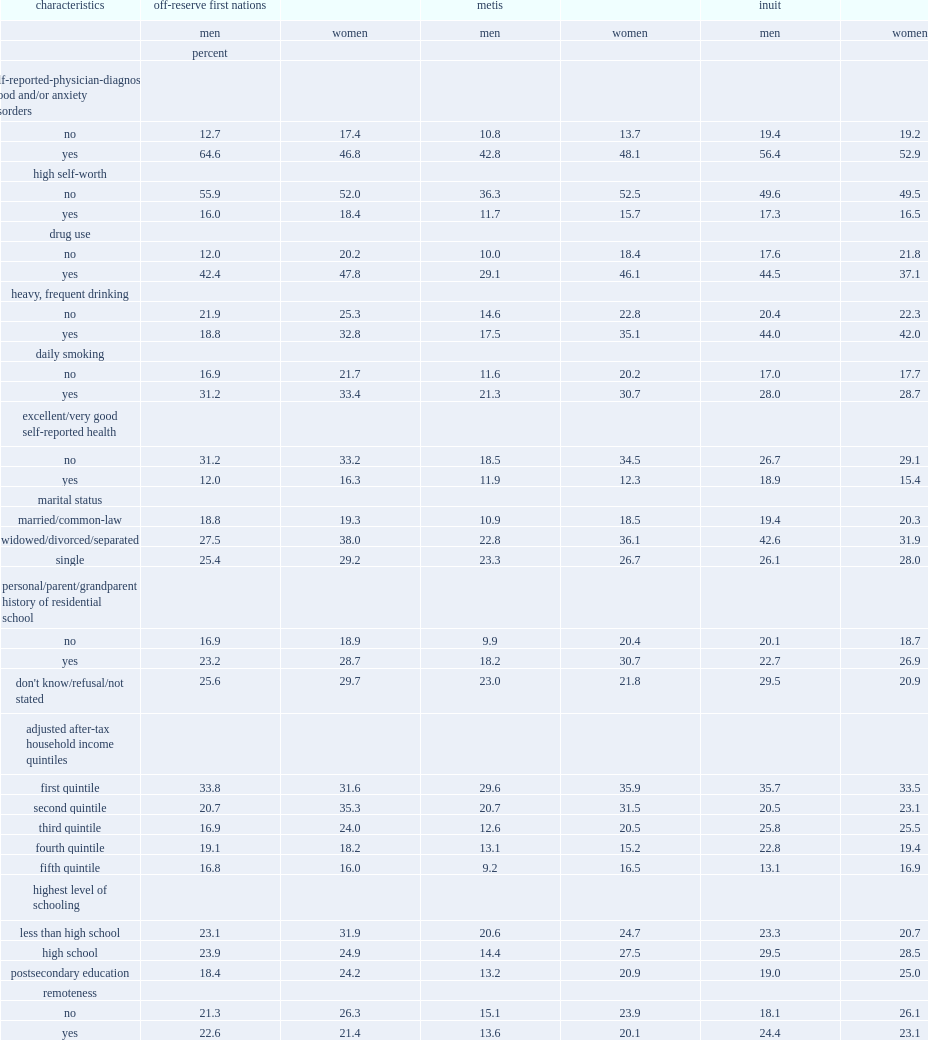What was the multiple relationship between inuit men and women who reported heavy, frequent drinking in the previous year and those who did not respectively? 2.156863 1.883408. For inuit men,who were less likely to have had lifetime suicidal thoughts,those who reported to be in excellent or very good health or those who rated their health less favourably? Yes. Among metis men ,which kind of marital status had the lowest possibility to have reported suicidal thoughts? Married/common-law. For metis women,who were more likely to have had suicidal thoughts,those with personal or familial residential school experience or those without such experience? Yes. 